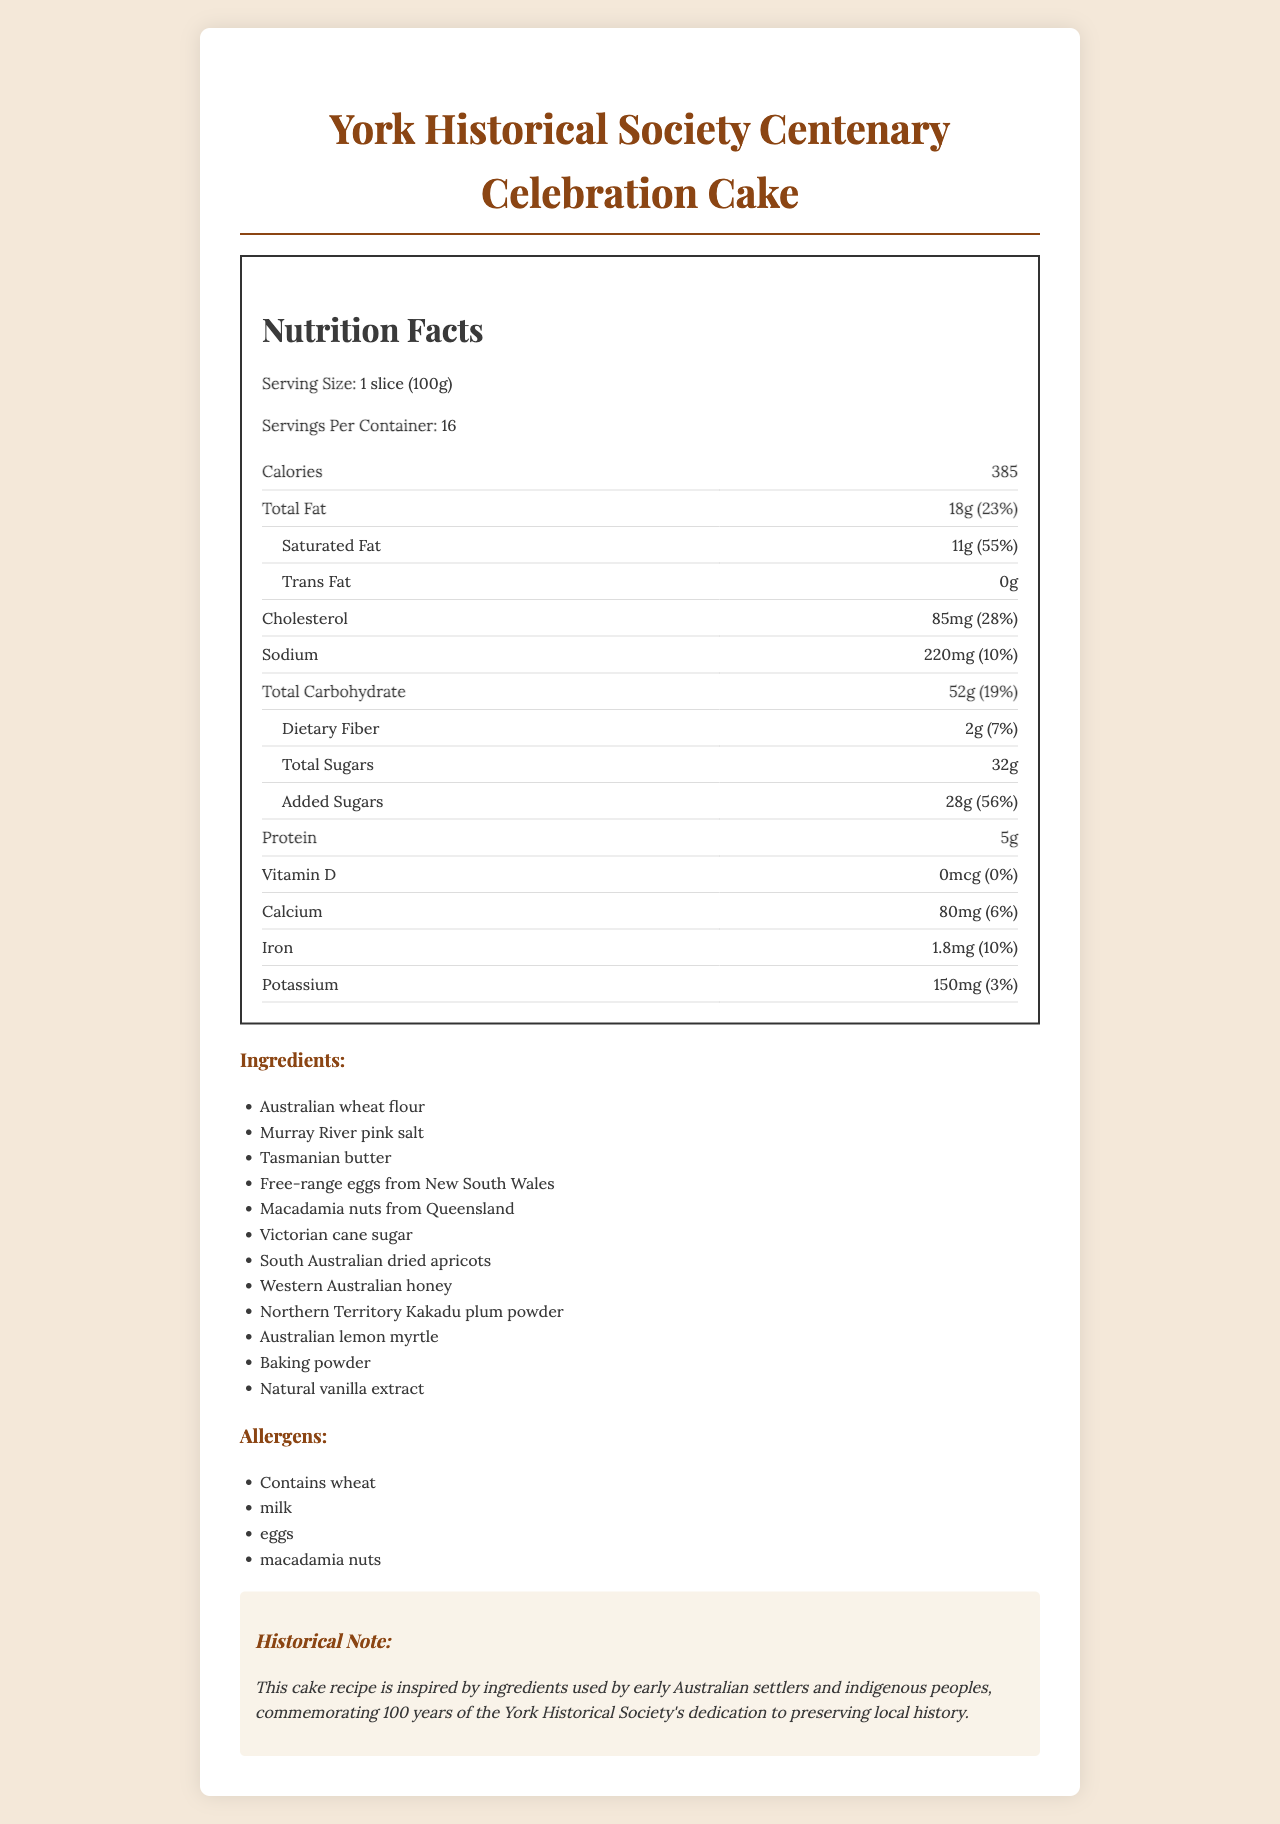what is the serving size? The serving size is specified in the Nutrition Facts section as "1 slice (100g)".
Answer: 1 slice (100g) how many servings are in the container? The document states that there are 16 servings per container.
Answer: 16 what is the total fat content per serving? It is listed in the Nutrition Facts section as "Total Fat: 18g".
Answer: 18g which ingredient provides natural sweetness to the cake aside from sugar? The ingredients list includes "Western Australian honey," which provides natural sweetness.
Answer: Western Australian honey what percentage of daily value for saturated fat does one serving have? It is mentioned under the "Saturated Fat" in the Nutrition Facts as "55%".
Answer: 55% which Australian state is the Macadamia nuts sourced from? A. New South Wales B. Queensland C. Victoria D. Western Australia The ingredients list shows "Macadamia nuts from Queensland".
Answer: B. Queensland how much cholesterol does one serving of cake have? The Nutrition Facts state "Cholesterol: 85mg".
Answer: 85mg does the cake contain any dietary fiber? The Nutrition Facts indicate "Dietary Fiber: 2g".
Answer: Yes is there any trans fat in the cake? The document specifies "Trans Fat: 0g".
Answer: No how much iron does a serving provide? The Nutrition Facts section states "Iron: 1.8mg".
Answer: 1.8mg which type of flour is used in the cake? The ingredients list specifies "Australian wheat flour".
Answer: Australian wheat flour which ingredient used is native to indigenous Australian cuisine? A. Tasmanian butter B. Victorian cane sugar C. Northern Territory Kakadu plum powder D. Murray River pink salt The ingredients list includes "Northern Territory Kakadu plum powder," which is native to indigenous Australian cuisine.
Answer: C. Northern Territory Kakadu plum powder is vitamin D present in the cake? The Nutrition Facts state "Vitamin D: 0mcg (0%)".
Answer: No how many calories are there in one serving of the cake? The document mentions "Calories: 385" in the Nutrition Facts section.
Answer: 385 which ingredient from New South Wales is used in the cake? The ingredients list states "Free-range eggs from New South Wales".
Answer: Free-range eggs what is the main idea of the document? The document is aimed at informing the reader about the nutritional content, specific ingredients from different regions of Australia, potential allergens, and the historical significance of the cake.
Answer: The document provides the nutritional information, ingredients, allergens, and a historical note about the York Historical Society Centenary Celebration Cake, which commemorates 100 years of the society using heritage-inspired ingredients. what type of sweetener is used in the cake apart from natural ingredients like honey? The ingredients list includes "Victorian cane sugar" in addition to honey.
Answer: Victorian cane sugar is the cake recipe inspired by modern culinary trends? The historical note mentions that the cake is inspired by ingredients used by early Australian settlers and indigenous peoples, not modern culinary trends.
Answer: No how many grams of added sugars are in one serving? The Nutrition Facts state "Added Sugars: 28g".
Answer: 28g what is the total carbohydrate content in one serving? The document states "Total Carbohydrate: 52g" in the Nutrition Facts section.
Answer: 52g how much potassium does one serving provide? The Nutrition Facts mention "Potassium: 150mg".
Answer: 150mg what allergens are present in this cake? The document lists these allergens under the Allergens section.
Answer: Contains wheat, milk, eggs, macadamia nuts how many servings are there in a full cake? A. 8 B. 12 C. 16 D. 20 The document states there are 16 servings per container.
Answer: C. 16 where is the butter used in the cake sourced from? The ingredients list specifies "Tasmanian butter".
Answer: Tasmania how many calories come from dietary fiber in one serving? The document does not specify the caloric contribution of dietary fiber directly.
Answer: Cannot be determined 